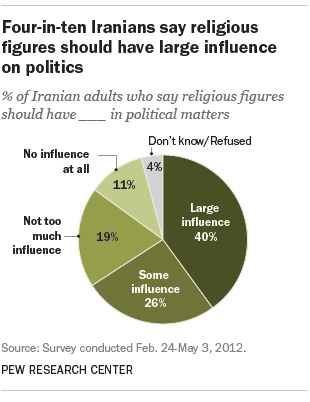List a handful of essential elements in this visual. The ratio of the two largest segments in the pairing of A and B is approximately 0.555555556... The color of the "Don't know/Refused" segment is gray. 